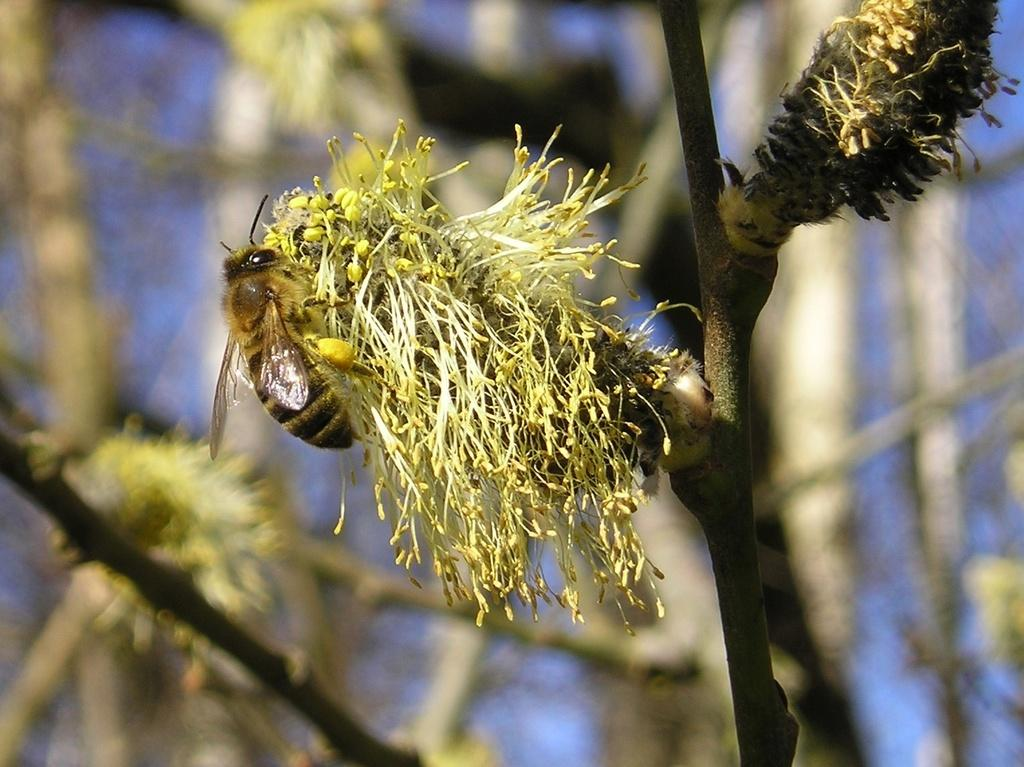What is the main subject of the picture? The main subject of the picture is a bee. Where is the bee located in the image? The bee is sitting on a flower. Can you describe the flower the bee is on? The flower is attached to a stem. What else can be seen in the picture besides the bee and the flower? There are many other flowers in the picture. How is the background of the image depicted? The backdrop of the image is blurred. What type of faucet is visible in the picture? There is no faucet present in the image; it features a bee sitting on a flower with other flowers in the background. 